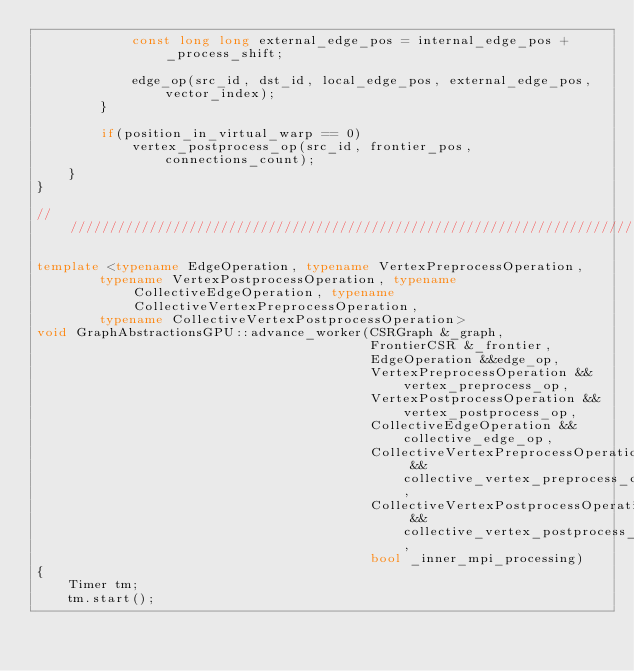Convert code to text. <code><loc_0><loc_0><loc_500><loc_500><_C++_>            const long long external_edge_pos = internal_edge_pos + _process_shift;

            edge_op(src_id, dst_id, local_edge_pos, external_edge_pos, vector_index);
        }

        if(position_in_virtual_warp == 0)
            vertex_postprocess_op(src_id, frontier_pos, connections_count);
    }
}

/////////////////////////////////////////////////////////////////////////////////////////////////////////////////////

template <typename EdgeOperation, typename VertexPreprocessOperation,
        typename VertexPostprocessOperation, typename CollectiveEdgeOperation, typename CollectiveVertexPreprocessOperation,
        typename CollectiveVertexPostprocessOperation>
void GraphAbstractionsGPU::advance_worker(CSRGraph &_graph,
                                          FrontierCSR &_frontier,
                                          EdgeOperation &&edge_op,
                                          VertexPreprocessOperation &&vertex_preprocess_op,
                                          VertexPostprocessOperation &&vertex_postprocess_op,
                                          CollectiveEdgeOperation &&collective_edge_op,
                                          CollectiveVertexPreprocessOperation &&collective_vertex_preprocess_op,
                                          CollectiveVertexPostprocessOperation &&collective_vertex_postprocess_op,
                                          bool _inner_mpi_processing)
{
    Timer tm;
    tm.start();</code> 